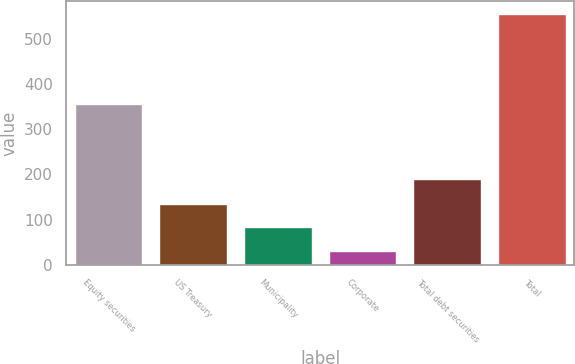Convert chart. <chart><loc_0><loc_0><loc_500><loc_500><bar_chart><fcel>Equity securities<fcel>US Treasury<fcel>Municipality<fcel>Corporate<fcel>Total debt securities<fcel>Total<nl><fcel>356<fcel>135.8<fcel>83.4<fcel>31<fcel>189<fcel>555<nl></chart> 